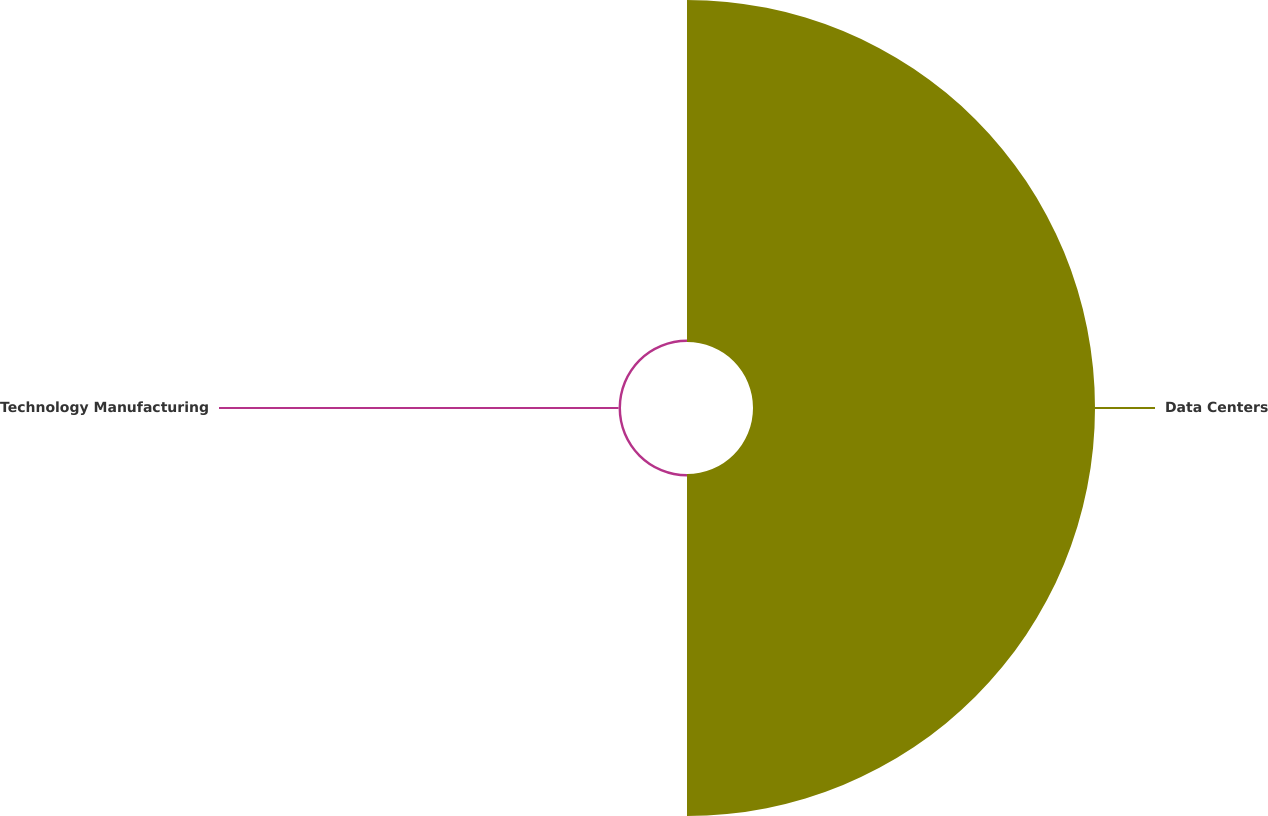Convert chart. <chart><loc_0><loc_0><loc_500><loc_500><pie_chart><fcel>Data Centers<fcel>Technology Manufacturing<nl><fcel>99.29%<fcel>0.71%<nl></chart> 